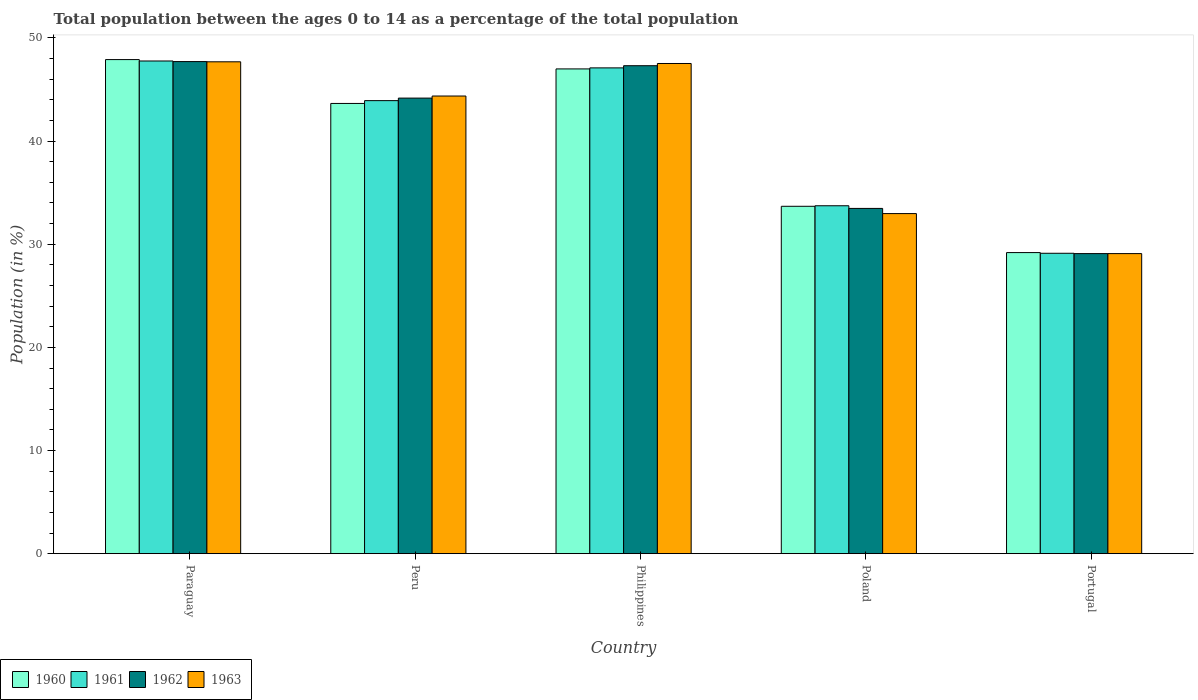Are the number of bars per tick equal to the number of legend labels?
Provide a succinct answer. Yes. Are the number of bars on each tick of the X-axis equal?
Ensure brevity in your answer.  Yes. What is the label of the 2nd group of bars from the left?
Keep it short and to the point. Peru. What is the percentage of the population ages 0 to 14 in 1962 in Peru?
Offer a terse response. 44.17. Across all countries, what is the maximum percentage of the population ages 0 to 14 in 1962?
Your response must be concise. 47.71. Across all countries, what is the minimum percentage of the population ages 0 to 14 in 1962?
Make the answer very short. 29.09. In which country was the percentage of the population ages 0 to 14 in 1963 maximum?
Provide a succinct answer. Paraguay. What is the total percentage of the population ages 0 to 14 in 1962 in the graph?
Make the answer very short. 201.76. What is the difference between the percentage of the population ages 0 to 14 in 1960 in Philippines and that in Poland?
Your response must be concise. 13.32. What is the difference between the percentage of the population ages 0 to 14 in 1960 in Philippines and the percentage of the population ages 0 to 14 in 1963 in Poland?
Make the answer very short. 14.03. What is the average percentage of the population ages 0 to 14 in 1963 per country?
Make the answer very short. 40.33. What is the difference between the percentage of the population ages 0 to 14 of/in 1961 and percentage of the population ages 0 to 14 of/in 1963 in Paraguay?
Your answer should be compact. 0.08. What is the ratio of the percentage of the population ages 0 to 14 in 1962 in Philippines to that in Poland?
Your response must be concise. 1.41. Is the difference between the percentage of the population ages 0 to 14 in 1961 in Paraguay and Portugal greater than the difference between the percentage of the population ages 0 to 14 in 1963 in Paraguay and Portugal?
Offer a terse response. Yes. What is the difference between the highest and the second highest percentage of the population ages 0 to 14 in 1961?
Your response must be concise. -3.18. What is the difference between the highest and the lowest percentage of the population ages 0 to 14 in 1963?
Make the answer very short. 18.6. In how many countries, is the percentage of the population ages 0 to 14 in 1961 greater than the average percentage of the population ages 0 to 14 in 1961 taken over all countries?
Offer a very short reply. 3. What does the 2nd bar from the left in Philippines represents?
Your answer should be compact. 1961. Is it the case that in every country, the sum of the percentage of the population ages 0 to 14 in 1962 and percentage of the population ages 0 to 14 in 1963 is greater than the percentage of the population ages 0 to 14 in 1961?
Make the answer very short. Yes. What is the difference between two consecutive major ticks on the Y-axis?
Your answer should be compact. 10. Are the values on the major ticks of Y-axis written in scientific E-notation?
Your answer should be very brief. No. Does the graph contain grids?
Ensure brevity in your answer.  No. What is the title of the graph?
Offer a terse response. Total population between the ages 0 to 14 as a percentage of the total population. What is the label or title of the X-axis?
Give a very brief answer. Country. What is the Population (in %) in 1960 in Paraguay?
Give a very brief answer. 47.91. What is the Population (in %) of 1961 in Paraguay?
Keep it short and to the point. 47.77. What is the Population (in %) of 1962 in Paraguay?
Your response must be concise. 47.71. What is the Population (in %) of 1963 in Paraguay?
Make the answer very short. 47.69. What is the Population (in %) of 1960 in Peru?
Your answer should be very brief. 43.65. What is the Population (in %) of 1961 in Peru?
Provide a short and direct response. 43.92. What is the Population (in %) of 1962 in Peru?
Provide a short and direct response. 44.17. What is the Population (in %) in 1963 in Peru?
Your answer should be very brief. 44.37. What is the Population (in %) in 1960 in Philippines?
Your response must be concise. 47. What is the Population (in %) of 1961 in Philippines?
Your response must be concise. 47.1. What is the Population (in %) of 1962 in Philippines?
Your answer should be compact. 47.31. What is the Population (in %) in 1963 in Philippines?
Provide a succinct answer. 47.53. What is the Population (in %) in 1960 in Poland?
Offer a terse response. 33.68. What is the Population (in %) in 1961 in Poland?
Provide a short and direct response. 33.73. What is the Population (in %) of 1962 in Poland?
Give a very brief answer. 33.47. What is the Population (in %) of 1963 in Poland?
Keep it short and to the point. 32.97. What is the Population (in %) of 1960 in Portugal?
Provide a succinct answer. 29.19. What is the Population (in %) in 1961 in Portugal?
Your answer should be compact. 29.13. What is the Population (in %) in 1962 in Portugal?
Provide a succinct answer. 29.09. What is the Population (in %) in 1963 in Portugal?
Offer a terse response. 29.09. Across all countries, what is the maximum Population (in %) in 1960?
Make the answer very short. 47.91. Across all countries, what is the maximum Population (in %) in 1961?
Offer a very short reply. 47.77. Across all countries, what is the maximum Population (in %) in 1962?
Offer a very short reply. 47.71. Across all countries, what is the maximum Population (in %) in 1963?
Give a very brief answer. 47.69. Across all countries, what is the minimum Population (in %) of 1960?
Offer a very short reply. 29.19. Across all countries, what is the minimum Population (in %) of 1961?
Make the answer very short. 29.13. Across all countries, what is the minimum Population (in %) of 1962?
Give a very brief answer. 29.09. Across all countries, what is the minimum Population (in %) of 1963?
Give a very brief answer. 29.09. What is the total Population (in %) of 1960 in the graph?
Provide a short and direct response. 201.43. What is the total Population (in %) in 1961 in the graph?
Provide a succinct answer. 201.65. What is the total Population (in %) in 1962 in the graph?
Your response must be concise. 201.76. What is the total Population (in %) of 1963 in the graph?
Keep it short and to the point. 201.66. What is the difference between the Population (in %) in 1960 in Paraguay and that in Peru?
Keep it short and to the point. 4.25. What is the difference between the Population (in %) of 1961 in Paraguay and that in Peru?
Your answer should be compact. 3.84. What is the difference between the Population (in %) in 1962 in Paraguay and that in Peru?
Your answer should be compact. 3.54. What is the difference between the Population (in %) of 1963 in Paraguay and that in Peru?
Your answer should be very brief. 3.32. What is the difference between the Population (in %) of 1960 in Paraguay and that in Philippines?
Your response must be concise. 0.91. What is the difference between the Population (in %) of 1961 in Paraguay and that in Philippines?
Your answer should be very brief. 0.67. What is the difference between the Population (in %) in 1962 in Paraguay and that in Philippines?
Offer a terse response. 0.4. What is the difference between the Population (in %) of 1963 in Paraguay and that in Philippines?
Keep it short and to the point. 0.16. What is the difference between the Population (in %) of 1960 in Paraguay and that in Poland?
Make the answer very short. 14.22. What is the difference between the Population (in %) in 1961 in Paraguay and that in Poland?
Offer a terse response. 14.04. What is the difference between the Population (in %) of 1962 in Paraguay and that in Poland?
Offer a terse response. 14.24. What is the difference between the Population (in %) in 1963 in Paraguay and that in Poland?
Your answer should be compact. 14.72. What is the difference between the Population (in %) in 1960 in Paraguay and that in Portugal?
Offer a terse response. 18.71. What is the difference between the Population (in %) of 1961 in Paraguay and that in Portugal?
Your answer should be very brief. 18.64. What is the difference between the Population (in %) of 1962 in Paraguay and that in Portugal?
Provide a short and direct response. 18.62. What is the difference between the Population (in %) in 1963 in Paraguay and that in Portugal?
Offer a very short reply. 18.6. What is the difference between the Population (in %) in 1960 in Peru and that in Philippines?
Keep it short and to the point. -3.35. What is the difference between the Population (in %) in 1961 in Peru and that in Philippines?
Provide a short and direct response. -3.18. What is the difference between the Population (in %) in 1962 in Peru and that in Philippines?
Provide a short and direct response. -3.14. What is the difference between the Population (in %) in 1963 in Peru and that in Philippines?
Your answer should be compact. -3.15. What is the difference between the Population (in %) of 1960 in Peru and that in Poland?
Offer a terse response. 9.97. What is the difference between the Population (in %) in 1961 in Peru and that in Poland?
Offer a very short reply. 10.19. What is the difference between the Population (in %) of 1962 in Peru and that in Poland?
Provide a short and direct response. 10.7. What is the difference between the Population (in %) in 1963 in Peru and that in Poland?
Your answer should be compact. 11.4. What is the difference between the Population (in %) of 1960 in Peru and that in Portugal?
Ensure brevity in your answer.  14.46. What is the difference between the Population (in %) in 1961 in Peru and that in Portugal?
Keep it short and to the point. 14.8. What is the difference between the Population (in %) in 1962 in Peru and that in Portugal?
Provide a succinct answer. 15.08. What is the difference between the Population (in %) of 1963 in Peru and that in Portugal?
Your answer should be very brief. 15.28. What is the difference between the Population (in %) of 1960 in Philippines and that in Poland?
Make the answer very short. 13.32. What is the difference between the Population (in %) of 1961 in Philippines and that in Poland?
Your answer should be compact. 13.37. What is the difference between the Population (in %) of 1962 in Philippines and that in Poland?
Make the answer very short. 13.84. What is the difference between the Population (in %) in 1963 in Philippines and that in Poland?
Provide a succinct answer. 14.55. What is the difference between the Population (in %) of 1960 in Philippines and that in Portugal?
Your answer should be very brief. 17.81. What is the difference between the Population (in %) in 1961 in Philippines and that in Portugal?
Provide a short and direct response. 17.97. What is the difference between the Population (in %) of 1962 in Philippines and that in Portugal?
Offer a very short reply. 18.22. What is the difference between the Population (in %) in 1963 in Philippines and that in Portugal?
Keep it short and to the point. 18.43. What is the difference between the Population (in %) in 1960 in Poland and that in Portugal?
Your answer should be compact. 4.49. What is the difference between the Population (in %) of 1961 in Poland and that in Portugal?
Your answer should be compact. 4.61. What is the difference between the Population (in %) of 1962 in Poland and that in Portugal?
Provide a succinct answer. 4.38. What is the difference between the Population (in %) in 1963 in Poland and that in Portugal?
Provide a short and direct response. 3.88. What is the difference between the Population (in %) of 1960 in Paraguay and the Population (in %) of 1961 in Peru?
Make the answer very short. 3.98. What is the difference between the Population (in %) in 1960 in Paraguay and the Population (in %) in 1962 in Peru?
Ensure brevity in your answer.  3.74. What is the difference between the Population (in %) in 1960 in Paraguay and the Population (in %) in 1963 in Peru?
Provide a succinct answer. 3.53. What is the difference between the Population (in %) of 1961 in Paraguay and the Population (in %) of 1962 in Peru?
Provide a succinct answer. 3.6. What is the difference between the Population (in %) of 1961 in Paraguay and the Population (in %) of 1963 in Peru?
Provide a short and direct response. 3.4. What is the difference between the Population (in %) of 1962 in Paraguay and the Population (in %) of 1963 in Peru?
Ensure brevity in your answer.  3.34. What is the difference between the Population (in %) in 1960 in Paraguay and the Population (in %) in 1961 in Philippines?
Keep it short and to the point. 0.81. What is the difference between the Population (in %) of 1960 in Paraguay and the Population (in %) of 1962 in Philippines?
Give a very brief answer. 0.59. What is the difference between the Population (in %) in 1960 in Paraguay and the Population (in %) in 1963 in Philippines?
Your answer should be very brief. 0.38. What is the difference between the Population (in %) in 1961 in Paraguay and the Population (in %) in 1962 in Philippines?
Your answer should be very brief. 0.46. What is the difference between the Population (in %) in 1961 in Paraguay and the Population (in %) in 1963 in Philippines?
Your answer should be very brief. 0.24. What is the difference between the Population (in %) in 1962 in Paraguay and the Population (in %) in 1963 in Philippines?
Offer a very short reply. 0.18. What is the difference between the Population (in %) of 1960 in Paraguay and the Population (in %) of 1961 in Poland?
Offer a very short reply. 14.17. What is the difference between the Population (in %) in 1960 in Paraguay and the Population (in %) in 1962 in Poland?
Offer a very short reply. 14.43. What is the difference between the Population (in %) in 1960 in Paraguay and the Population (in %) in 1963 in Poland?
Provide a short and direct response. 14.93. What is the difference between the Population (in %) of 1961 in Paraguay and the Population (in %) of 1962 in Poland?
Make the answer very short. 14.29. What is the difference between the Population (in %) of 1961 in Paraguay and the Population (in %) of 1963 in Poland?
Make the answer very short. 14.79. What is the difference between the Population (in %) of 1962 in Paraguay and the Population (in %) of 1963 in Poland?
Make the answer very short. 14.74. What is the difference between the Population (in %) in 1960 in Paraguay and the Population (in %) in 1961 in Portugal?
Provide a short and direct response. 18.78. What is the difference between the Population (in %) in 1960 in Paraguay and the Population (in %) in 1962 in Portugal?
Make the answer very short. 18.81. What is the difference between the Population (in %) in 1960 in Paraguay and the Population (in %) in 1963 in Portugal?
Provide a succinct answer. 18.81. What is the difference between the Population (in %) in 1961 in Paraguay and the Population (in %) in 1962 in Portugal?
Make the answer very short. 18.68. What is the difference between the Population (in %) of 1961 in Paraguay and the Population (in %) of 1963 in Portugal?
Offer a terse response. 18.68. What is the difference between the Population (in %) of 1962 in Paraguay and the Population (in %) of 1963 in Portugal?
Offer a terse response. 18.62. What is the difference between the Population (in %) in 1960 in Peru and the Population (in %) in 1961 in Philippines?
Give a very brief answer. -3.45. What is the difference between the Population (in %) in 1960 in Peru and the Population (in %) in 1962 in Philippines?
Provide a succinct answer. -3.66. What is the difference between the Population (in %) of 1960 in Peru and the Population (in %) of 1963 in Philippines?
Provide a short and direct response. -3.87. What is the difference between the Population (in %) in 1961 in Peru and the Population (in %) in 1962 in Philippines?
Make the answer very short. -3.39. What is the difference between the Population (in %) of 1961 in Peru and the Population (in %) of 1963 in Philippines?
Your answer should be compact. -3.6. What is the difference between the Population (in %) of 1962 in Peru and the Population (in %) of 1963 in Philippines?
Give a very brief answer. -3.36. What is the difference between the Population (in %) of 1960 in Peru and the Population (in %) of 1961 in Poland?
Your answer should be compact. 9.92. What is the difference between the Population (in %) in 1960 in Peru and the Population (in %) in 1962 in Poland?
Give a very brief answer. 10.18. What is the difference between the Population (in %) of 1960 in Peru and the Population (in %) of 1963 in Poland?
Provide a short and direct response. 10.68. What is the difference between the Population (in %) in 1961 in Peru and the Population (in %) in 1962 in Poland?
Offer a very short reply. 10.45. What is the difference between the Population (in %) of 1961 in Peru and the Population (in %) of 1963 in Poland?
Provide a short and direct response. 10.95. What is the difference between the Population (in %) in 1962 in Peru and the Population (in %) in 1963 in Poland?
Offer a terse response. 11.2. What is the difference between the Population (in %) in 1960 in Peru and the Population (in %) in 1961 in Portugal?
Your answer should be compact. 14.53. What is the difference between the Population (in %) of 1960 in Peru and the Population (in %) of 1962 in Portugal?
Make the answer very short. 14.56. What is the difference between the Population (in %) of 1960 in Peru and the Population (in %) of 1963 in Portugal?
Keep it short and to the point. 14.56. What is the difference between the Population (in %) in 1961 in Peru and the Population (in %) in 1962 in Portugal?
Your response must be concise. 14.83. What is the difference between the Population (in %) in 1961 in Peru and the Population (in %) in 1963 in Portugal?
Offer a terse response. 14.83. What is the difference between the Population (in %) in 1962 in Peru and the Population (in %) in 1963 in Portugal?
Give a very brief answer. 15.08. What is the difference between the Population (in %) of 1960 in Philippines and the Population (in %) of 1961 in Poland?
Provide a succinct answer. 13.27. What is the difference between the Population (in %) of 1960 in Philippines and the Population (in %) of 1962 in Poland?
Provide a succinct answer. 13.53. What is the difference between the Population (in %) of 1960 in Philippines and the Population (in %) of 1963 in Poland?
Provide a short and direct response. 14.03. What is the difference between the Population (in %) in 1961 in Philippines and the Population (in %) in 1962 in Poland?
Your answer should be compact. 13.63. What is the difference between the Population (in %) of 1961 in Philippines and the Population (in %) of 1963 in Poland?
Offer a terse response. 14.13. What is the difference between the Population (in %) in 1962 in Philippines and the Population (in %) in 1963 in Poland?
Your response must be concise. 14.34. What is the difference between the Population (in %) in 1960 in Philippines and the Population (in %) in 1961 in Portugal?
Offer a terse response. 17.88. What is the difference between the Population (in %) of 1960 in Philippines and the Population (in %) of 1962 in Portugal?
Your response must be concise. 17.91. What is the difference between the Population (in %) in 1960 in Philippines and the Population (in %) in 1963 in Portugal?
Make the answer very short. 17.91. What is the difference between the Population (in %) in 1961 in Philippines and the Population (in %) in 1962 in Portugal?
Provide a short and direct response. 18.01. What is the difference between the Population (in %) of 1961 in Philippines and the Population (in %) of 1963 in Portugal?
Keep it short and to the point. 18.01. What is the difference between the Population (in %) in 1962 in Philippines and the Population (in %) in 1963 in Portugal?
Provide a succinct answer. 18.22. What is the difference between the Population (in %) in 1960 in Poland and the Population (in %) in 1961 in Portugal?
Make the answer very short. 4.56. What is the difference between the Population (in %) of 1960 in Poland and the Population (in %) of 1962 in Portugal?
Keep it short and to the point. 4.59. What is the difference between the Population (in %) in 1960 in Poland and the Population (in %) in 1963 in Portugal?
Your answer should be compact. 4.59. What is the difference between the Population (in %) of 1961 in Poland and the Population (in %) of 1962 in Portugal?
Make the answer very short. 4.64. What is the difference between the Population (in %) in 1961 in Poland and the Population (in %) in 1963 in Portugal?
Give a very brief answer. 4.64. What is the difference between the Population (in %) in 1962 in Poland and the Population (in %) in 1963 in Portugal?
Provide a short and direct response. 4.38. What is the average Population (in %) of 1960 per country?
Your response must be concise. 40.29. What is the average Population (in %) of 1961 per country?
Your response must be concise. 40.33. What is the average Population (in %) in 1962 per country?
Give a very brief answer. 40.35. What is the average Population (in %) of 1963 per country?
Offer a terse response. 40.33. What is the difference between the Population (in %) of 1960 and Population (in %) of 1961 in Paraguay?
Provide a short and direct response. 0.14. What is the difference between the Population (in %) of 1960 and Population (in %) of 1962 in Paraguay?
Give a very brief answer. 0.2. What is the difference between the Population (in %) of 1960 and Population (in %) of 1963 in Paraguay?
Your answer should be compact. 0.22. What is the difference between the Population (in %) of 1961 and Population (in %) of 1962 in Paraguay?
Make the answer very short. 0.06. What is the difference between the Population (in %) in 1961 and Population (in %) in 1963 in Paraguay?
Offer a terse response. 0.08. What is the difference between the Population (in %) in 1962 and Population (in %) in 1963 in Paraguay?
Your answer should be very brief. 0.02. What is the difference between the Population (in %) of 1960 and Population (in %) of 1961 in Peru?
Provide a short and direct response. -0.27. What is the difference between the Population (in %) in 1960 and Population (in %) in 1962 in Peru?
Your answer should be compact. -0.52. What is the difference between the Population (in %) in 1960 and Population (in %) in 1963 in Peru?
Make the answer very short. -0.72. What is the difference between the Population (in %) in 1961 and Population (in %) in 1962 in Peru?
Your response must be concise. -0.25. What is the difference between the Population (in %) in 1961 and Population (in %) in 1963 in Peru?
Your response must be concise. -0.45. What is the difference between the Population (in %) of 1962 and Population (in %) of 1963 in Peru?
Provide a short and direct response. -0.2. What is the difference between the Population (in %) in 1960 and Population (in %) in 1961 in Philippines?
Provide a succinct answer. -0.1. What is the difference between the Population (in %) in 1960 and Population (in %) in 1962 in Philippines?
Your response must be concise. -0.31. What is the difference between the Population (in %) of 1960 and Population (in %) of 1963 in Philippines?
Your answer should be very brief. -0.53. What is the difference between the Population (in %) in 1961 and Population (in %) in 1962 in Philippines?
Give a very brief answer. -0.21. What is the difference between the Population (in %) in 1961 and Population (in %) in 1963 in Philippines?
Make the answer very short. -0.43. What is the difference between the Population (in %) in 1962 and Population (in %) in 1963 in Philippines?
Ensure brevity in your answer.  -0.21. What is the difference between the Population (in %) of 1960 and Population (in %) of 1961 in Poland?
Provide a short and direct response. -0.05. What is the difference between the Population (in %) of 1960 and Population (in %) of 1962 in Poland?
Keep it short and to the point. 0.21. What is the difference between the Population (in %) in 1960 and Population (in %) in 1963 in Poland?
Make the answer very short. 0.71. What is the difference between the Population (in %) of 1961 and Population (in %) of 1962 in Poland?
Give a very brief answer. 0.26. What is the difference between the Population (in %) in 1961 and Population (in %) in 1963 in Poland?
Keep it short and to the point. 0.76. What is the difference between the Population (in %) of 1962 and Population (in %) of 1963 in Poland?
Offer a very short reply. 0.5. What is the difference between the Population (in %) of 1960 and Population (in %) of 1961 in Portugal?
Offer a very short reply. 0.07. What is the difference between the Population (in %) of 1960 and Population (in %) of 1962 in Portugal?
Your response must be concise. 0.1. What is the difference between the Population (in %) of 1960 and Population (in %) of 1963 in Portugal?
Ensure brevity in your answer.  0.1. What is the difference between the Population (in %) in 1961 and Population (in %) in 1962 in Portugal?
Your answer should be compact. 0.03. What is the difference between the Population (in %) in 1961 and Population (in %) in 1963 in Portugal?
Your response must be concise. 0.03. What is the difference between the Population (in %) of 1962 and Population (in %) of 1963 in Portugal?
Make the answer very short. 0. What is the ratio of the Population (in %) in 1960 in Paraguay to that in Peru?
Your response must be concise. 1.1. What is the ratio of the Population (in %) in 1961 in Paraguay to that in Peru?
Make the answer very short. 1.09. What is the ratio of the Population (in %) in 1962 in Paraguay to that in Peru?
Ensure brevity in your answer.  1.08. What is the ratio of the Population (in %) of 1963 in Paraguay to that in Peru?
Offer a terse response. 1.07. What is the ratio of the Population (in %) in 1960 in Paraguay to that in Philippines?
Keep it short and to the point. 1.02. What is the ratio of the Population (in %) in 1961 in Paraguay to that in Philippines?
Offer a very short reply. 1.01. What is the ratio of the Population (in %) of 1962 in Paraguay to that in Philippines?
Give a very brief answer. 1.01. What is the ratio of the Population (in %) of 1963 in Paraguay to that in Philippines?
Your answer should be very brief. 1. What is the ratio of the Population (in %) in 1960 in Paraguay to that in Poland?
Make the answer very short. 1.42. What is the ratio of the Population (in %) of 1961 in Paraguay to that in Poland?
Your answer should be compact. 1.42. What is the ratio of the Population (in %) in 1962 in Paraguay to that in Poland?
Provide a succinct answer. 1.43. What is the ratio of the Population (in %) of 1963 in Paraguay to that in Poland?
Give a very brief answer. 1.45. What is the ratio of the Population (in %) in 1960 in Paraguay to that in Portugal?
Offer a terse response. 1.64. What is the ratio of the Population (in %) of 1961 in Paraguay to that in Portugal?
Provide a succinct answer. 1.64. What is the ratio of the Population (in %) of 1962 in Paraguay to that in Portugal?
Ensure brevity in your answer.  1.64. What is the ratio of the Population (in %) in 1963 in Paraguay to that in Portugal?
Your answer should be compact. 1.64. What is the ratio of the Population (in %) of 1960 in Peru to that in Philippines?
Offer a terse response. 0.93. What is the ratio of the Population (in %) of 1961 in Peru to that in Philippines?
Provide a short and direct response. 0.93. What is the ratio of the Population (in %) of 1962 in Peru to that in Philippines?
Make the answer very short. 0.93. What is the ratio of the Population (in %) of 1963 in Peru to that in Philippines?
Ensure brevity in your answer.  0.93. What is the ratio of the Population (in %) in 1960 in Peru to that in Poland?
Provide a short and direct response. 1.3. What is the ratio of the Population (in %) of 1961 in Peru to that in Poland?
Make the answer very short. 1.3. What is the ratio of the Population (in %) in 1962 in Peru to that in Poland?
Your answer should be compact. 1.32. What is the ratio of the Population (in %) in 1963 in Peru to that in Poland?
Your response must be concise. 1.35. What is the ratio of the Population (in %) in 1960 in Peru to that in Portugal?
Your answer should be compact. 1.5. What is the ratio of the Population (in %) in 1961 in Peru to that in Portugal?
Offer a terse response. 1.51. What is the ratio of the Population (in %) of 1962 in Peru to that in Portugal?
Your answer should be very brief. 1.52. What is the ratio of the Population (in %) in 1963 in Peru to that in Portugal?
Make the answer very short. 1.53. What is the ratio of the Population (in %) of 1960 in Philippines to that in Poland?
Offer a terse response. 1.4. What is the ratio of the Population (in %) of 1961 in Philippines to that in Poland?
Offer a very short reply. 1.4. What is the ratio of the Population (in %) of 1962 in Philippines to that in Poland?
Offer a very short reply. 1.41. What is the ratio of the Population (in %) in 1963 in Philippines to that in Poland?
Your answer should be compact. 1.44. What is the ratio of the Population (in %) in 1960 in Philippines to that in Portugal?
Ensure brevity in your answer.  1.61. What is the ratio of the Population (in %) of 1961 in Philippines to that in Portugal?
Ensure brevity in your answer.  1.62. What is the ratio of the Population (in %) of 1962 in Philippines to that in Portugal?
Keep it short and to the point. 1.63. What is the ratio of the Population (in %) in 1963 in Philippines to that in Portugal?
Offer a terse response. 1.63. What is the ratio of the Population (in %) of 1960 in Poland to that in Portugal?
Provide a short and direct response. 1.15. What is the ratio of the Population (in %) of 1961 in Poland to that in Portugal?
Ensure brevity in your answer.  1.16. What is the ratio of the Population (in %) in 1962 in Poland to that in Portugal?
Your response must be concise. 1.15. What is the ratio of the Population (in %) of 1963 in Poland to that in Portugal?
Your response must be concise. 1.13. What is the difference between the highest and the second highest Population (in %) in 1960?
Provide a succinct answer. 0.91. What is the difference between the highest and the second highest Population (in %) in 1961?
Provide a succinct answer. 0.67. What is the difference between the highest and the second highest Population (in %) in 1962?
Your answer should be compact. 0.4. What is the difference between the highest and the second highest Population (in %) of 1963?
Give a very brief answer. 0.16. What is the difference between the highest and the lowest Population (in %) of 1960?
Ensure brevity in your answer.  18.71. What is the difference between the highest and the lowest Population (in %) in 1961?
Offer a very short reply. 18.64. What is the difference between the highest and the lowest Population (in %) in 1962?
Provide a short and direct response. 18.62. What is the difference between the highest and the lowest Population (in %) in 1963?
Offer a terse response. 18.6. 